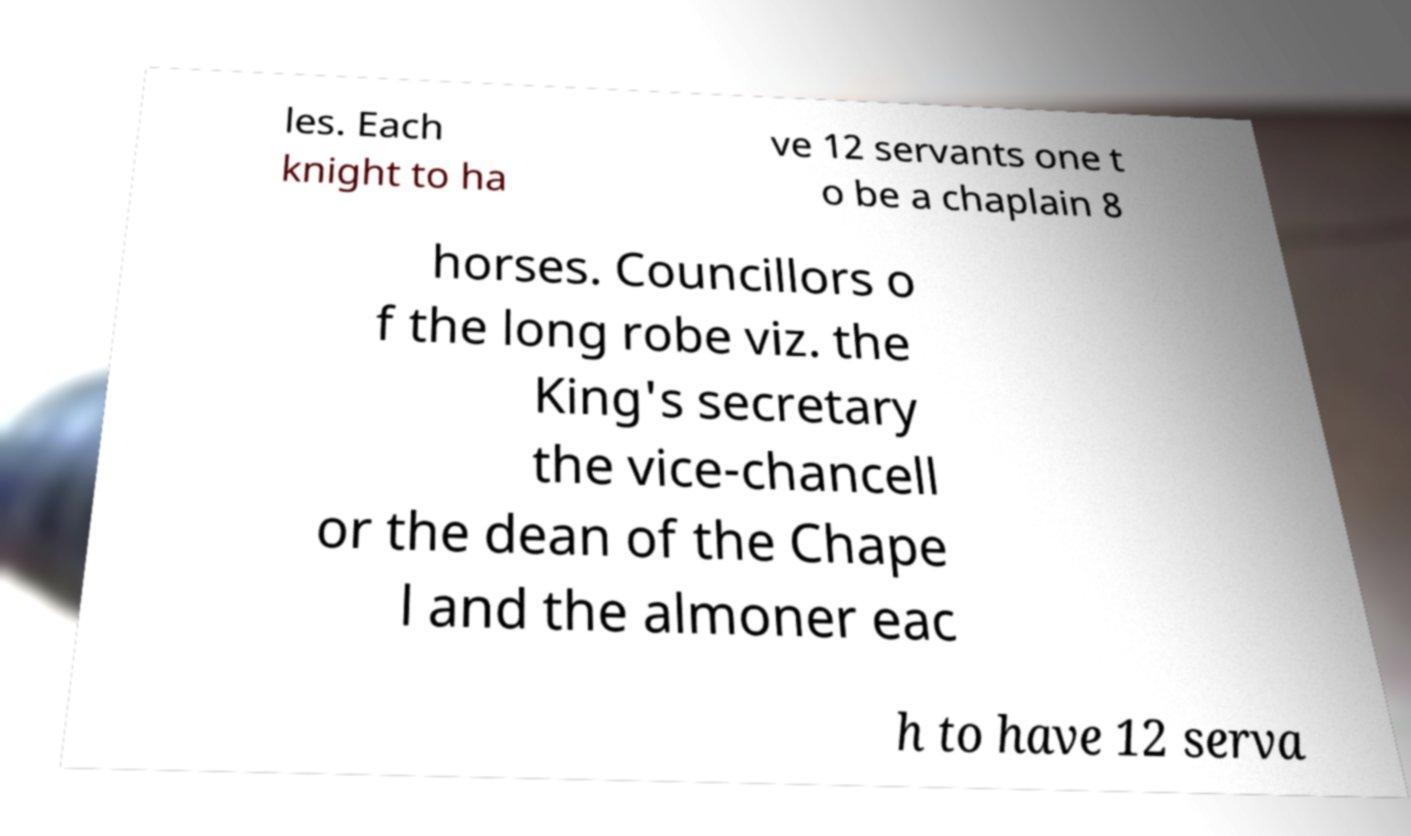There's text embedded in this image that I need extracted. Can you transcribe it verbatim? les. Each knight to ha ve 12 servants one t o be a chaplain 8 horses. Councillors o f the long robe viz. the King's secretary the vice-chancell or the dean of the Chape l and the almoner eac h to have 12 serva 